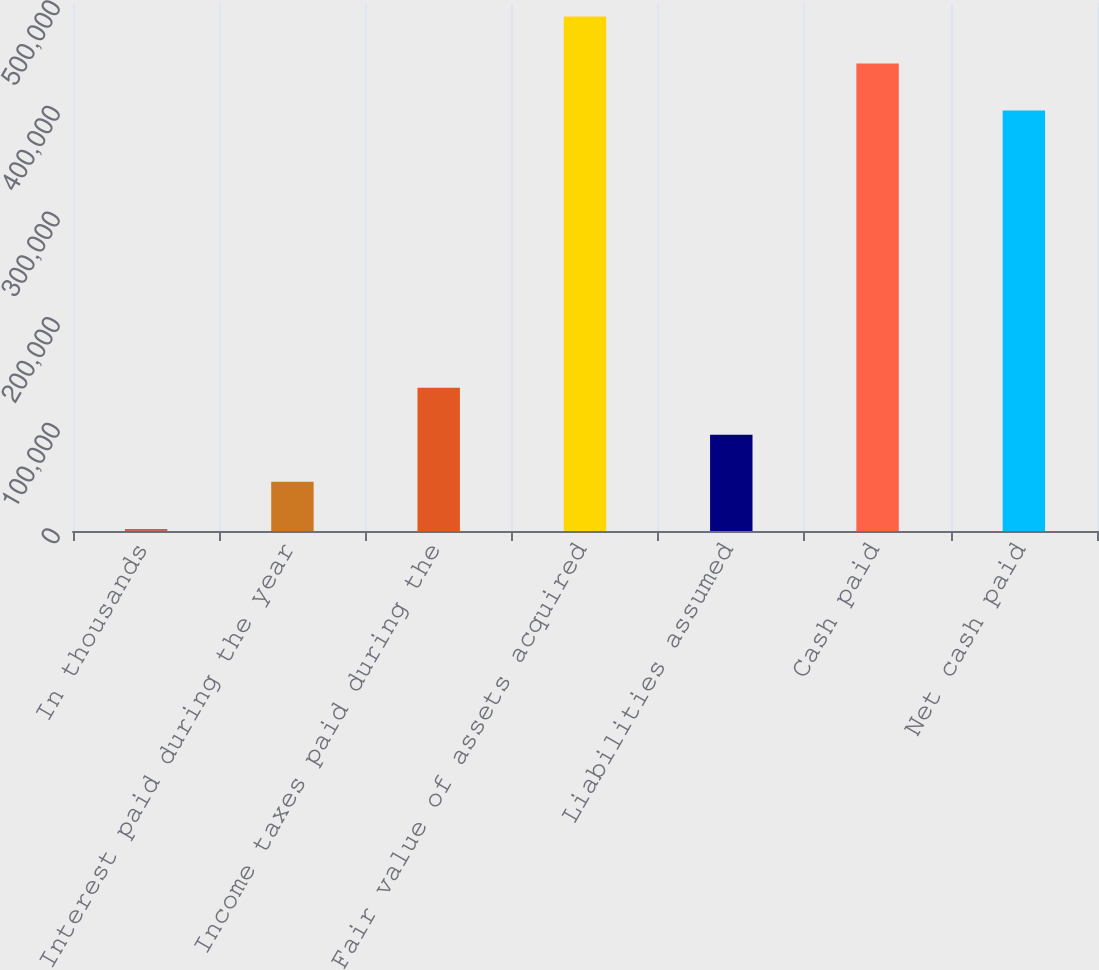Convert chart. <chart><loc_0><loc_0><loc_500><loc_500><bar_chart><fcel>In thousands<fcel>Interest paid during the year<fcel>Income taxes paid during the<fcel>Fair value of assets acquired<fcel>Liabilities assumed<fcel>Cash paid<fcel>Net cash paid<nl><fcel>2008<fcel>46547.8<fcel>135627<fcel>487212<fcel>91087.6<fcel>442672<fcel>398132<nl></chart> 